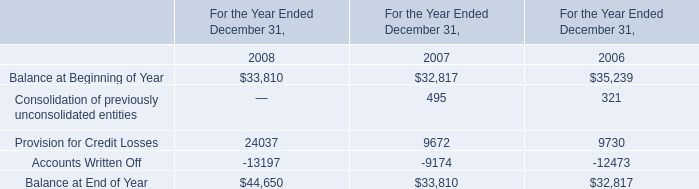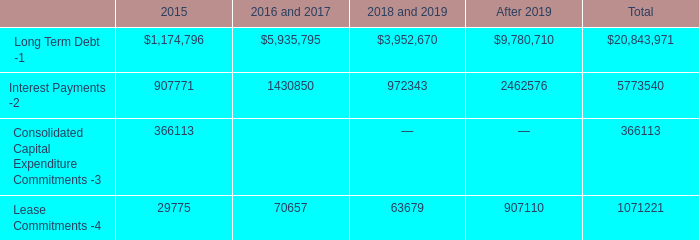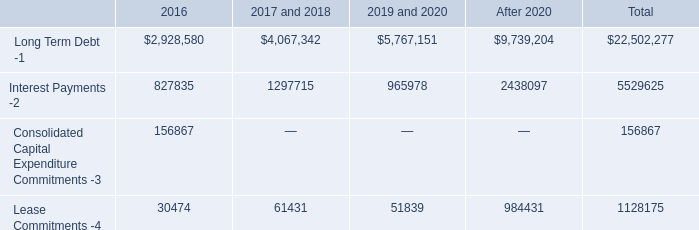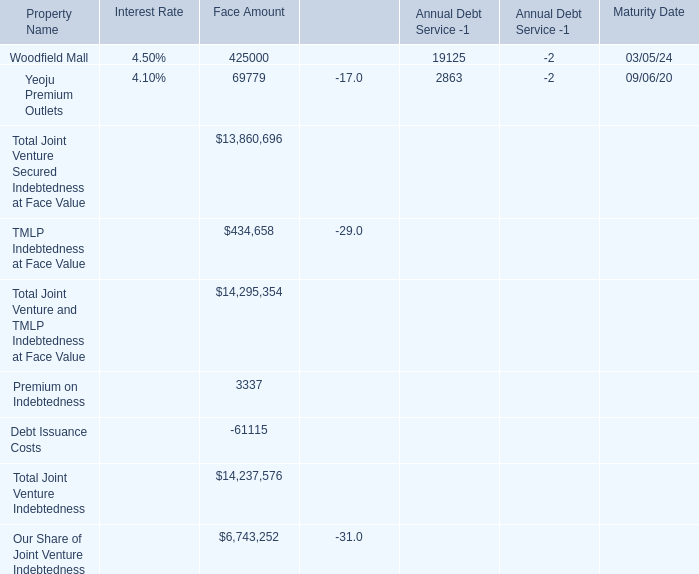What is the Face Amount for Premium on Indebtedness? 
Answer: 3337. 